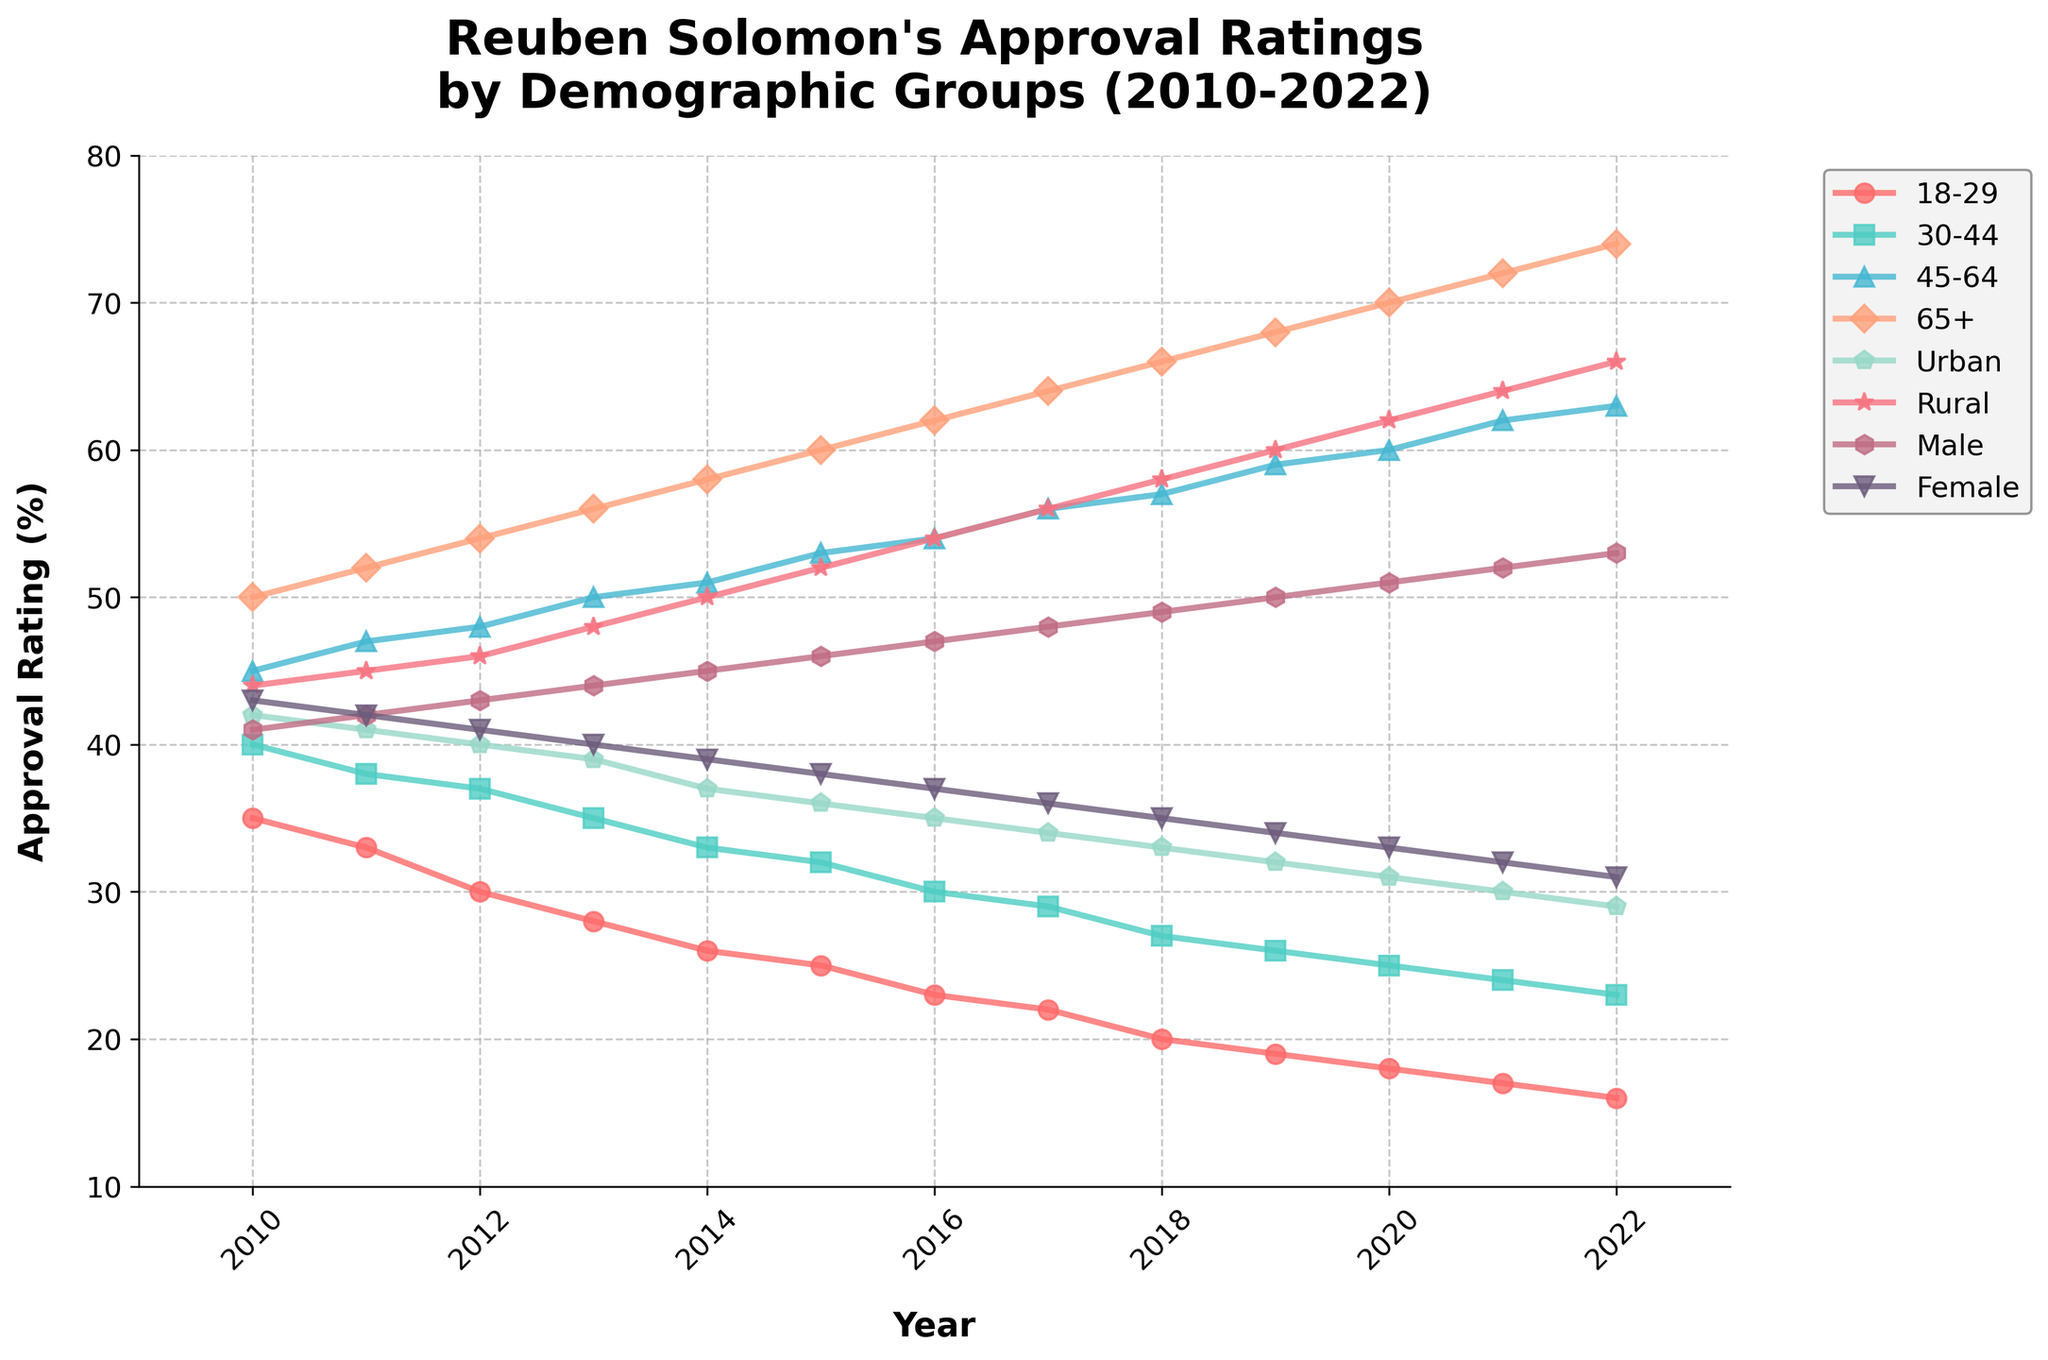Which demographic group showed the most significant increase in approval ratings from 2010 to 2022? By examining the end points for each group's line on the chart, we see that all groups show a decline rather than an increase. Therefore, no demographic group showed an increase in approval ratings from 2010 to 2022.
Answer: None Which age group had the highest approval rating in 2022? The chart shows lines categorized by age groups and their approval ratings over time. By locating the year 2022 on the x-axis and observing the y-axis values for each age group, we can determine the highest rating. In 2022, the group 65+ had the highest approval rating.
Answer: 65+ Between which consecutive years did approval ratings for the 18-29 age group decline the most? To determine this, we need to observe the slope of the line representing the 18-29 age group. The most significant decline occurs where the slope is steepest. From the chart, we see the steepest decline between 2011 and 2012.
Answer: 2011-2012 What is the difference between the approval ratings of the Urban and Rural demographics in 2018? Look at the chart for the year 2018 and note the approval ratings for both Urban and Rural demographics. Subtract the Urban approval rating from the Rural approval rating. In 2018, Urban had 33 and Rural had 58, so the difference is 58 - 33.
Answer: 25 Which gender saw a steadier decline in approval ratings over the years, Male or Female? By observing the trend lines for Male and Female, we can see that Female approval ratings declined more steadily with fewer fluctuations compared to the Male line.
Answer: Female What is the average approval rating for the 45-64 age group from 2010 to 2022? Calculate the average by summing the approval ratings for the 45-64 age group from 2010 to 2022 and then dividing by the number of years. The data for the 45-64 group is: 45, 47, 48, 50, 51, 53, 54, 56, 57, 59, 60, 62, 63. Sum these numbers to get 705, then divide by 13.
Answer: 54.23 During which year did the approval rating for the 30-44 age group surpass the 18-29 age group? Track both the 18-29 and 30-44 lines on the chart to identify the year when the 30-44 line first crosses above the 18-29 line. This crossing happens between 2011 and 2012.
Answer: 2012 What color line represents the Rural demographic? Identify the line associated with the Rural label in the legend. From the provided code, we know it is light green or turquoise colored on the chart.
Answer: Light green or turquoise What was the approval rating of the Female demographic in 2010 compared to 2022? Look at the chart at the starting year (2010) and the final year (2022) for the Female demographic. The ratings are 43 in 2010 and 31 in 2022. Compare these two values.
Answer: 43 in 2010, 31 in 2022 Which demographic group had the smallest decline in approval ratings from 2010 to 2022? Determine the difference between the 2010 and 2022 values for each group by subtracting the 2022 rating from the 2010 rating. Compare these differences to find the smallest. The 45-64 group started with 45 and ended with 63, giving the smallest decline of -18.
Answer: 45-64 